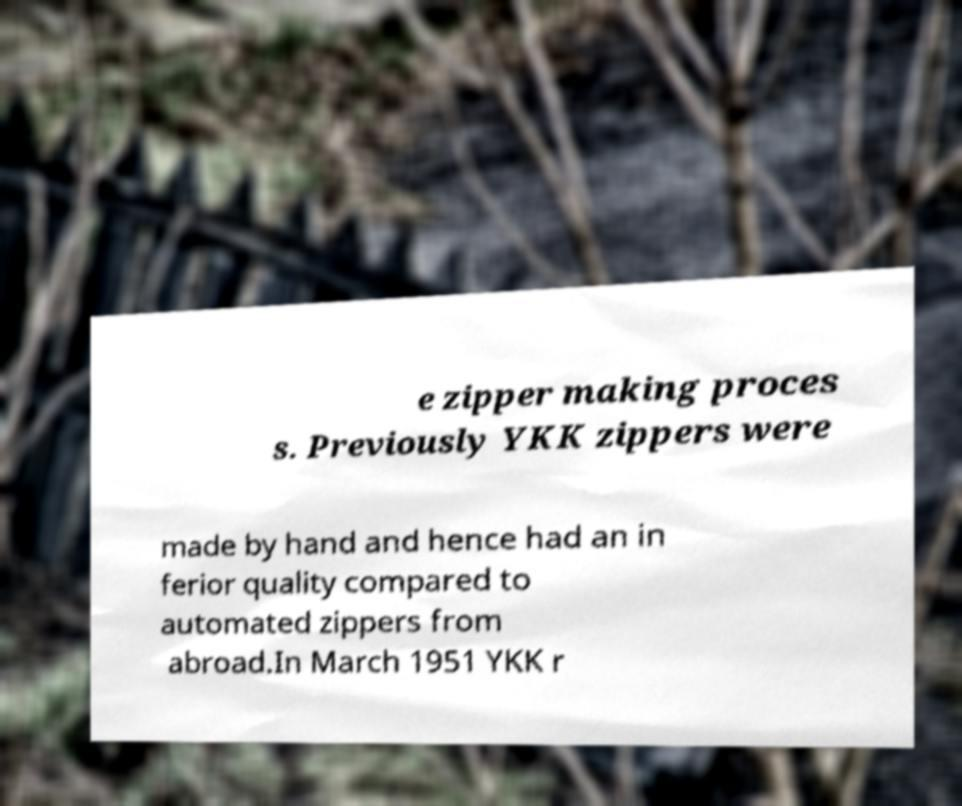Could you extract and type out the text from this image? e zipper making proces s. Previously YKK zippers were made by hand and hence had an in ferior quality compared to automated zippers from abroad.In March 1951 YKK r 